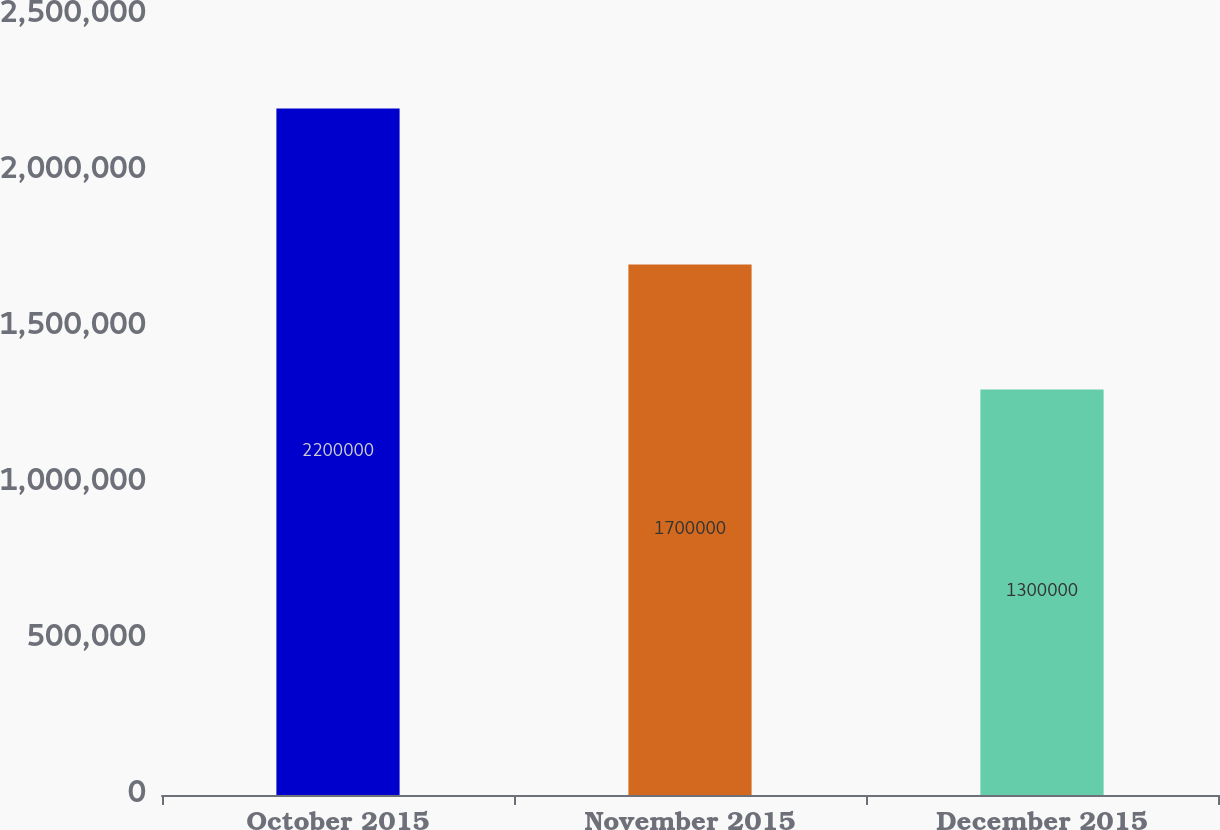Convert chart. <chart><loc_0><loc_0><loc_500><loc_500><bar_chart><fcel>October 2015<fcel>November 2015<fcel>December 2015<nl><fcel>2.2e+06<fcel>1.7e+06<fcel>1.3e+06<nl></chart> 